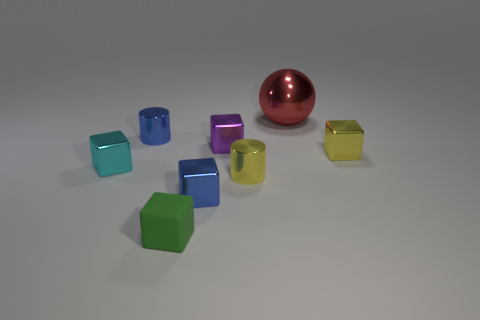Subtract all small purple metallic blocks. How many blocks are left? 4 Subtract 4 cubes. How many cubes are left? 1 Add 2 red spheres. How many objects exist? 10 Subtract all cyan cubes. How many cubes are left? 4 Subtract all cubes. How many objects are left? 3 Subtract all yellow metallic cylinders. Subtract all purple metal blocks. How many objects are left? 6 Add 8 yellow cylinders. How many yellow cylinders are left? 9 Add 7 cyan things. How many cyan things exist? 8 Subtract 1 green blocks. How many objects are left? 7 Subtract all gray cubes. Subtract all yellow balls. How many cubes are left? 5 